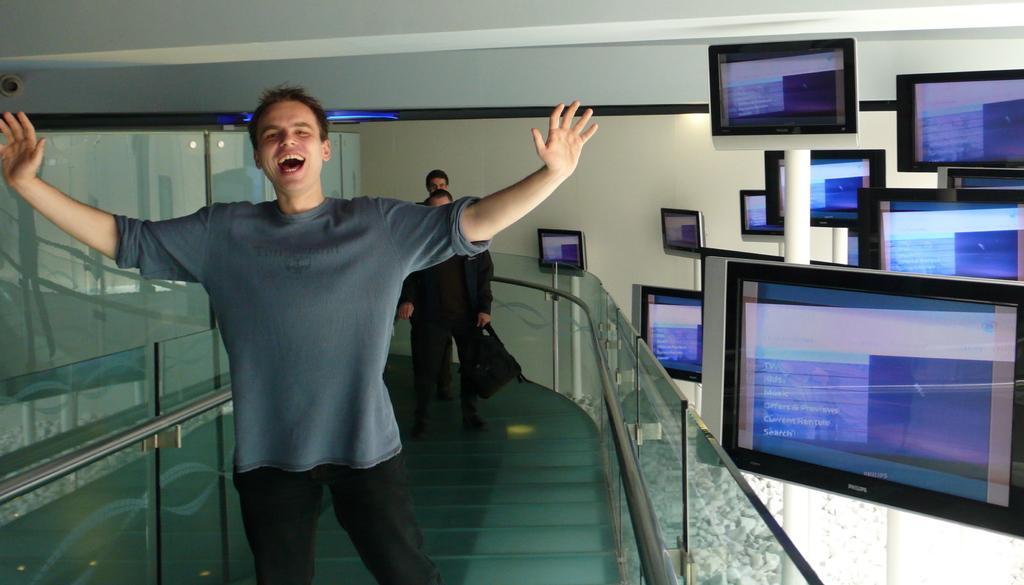Please provide a concise description of this image. In this picture we can see a man smiling and at the back of him we can see two people are standing on the floor, railings, televisions and in the background we can see the wall, ceiling, lights, some objects. 